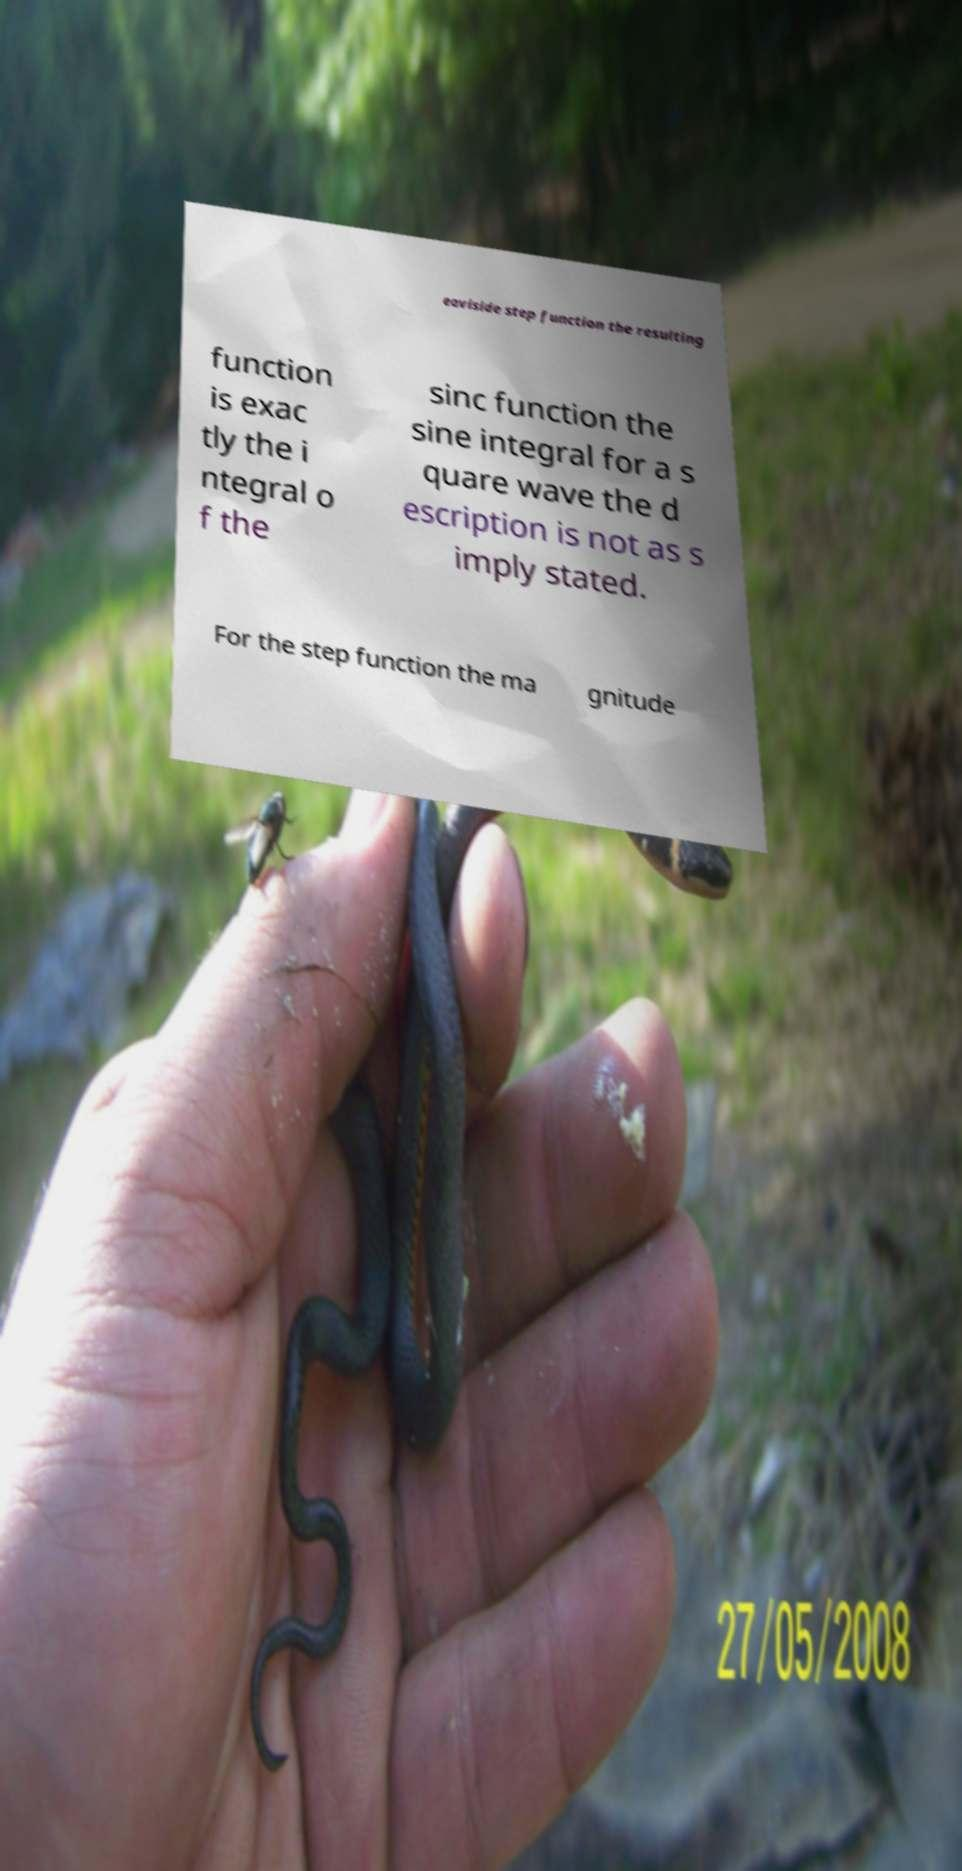I need the written content from this picture converted into text. Can you do that? eaviside step function the resulting function is exac tly the i ntegral o f the sinc function the sine integral for a s quare wave the d escription is not as s imply stated. For the step function the ma gnitude 